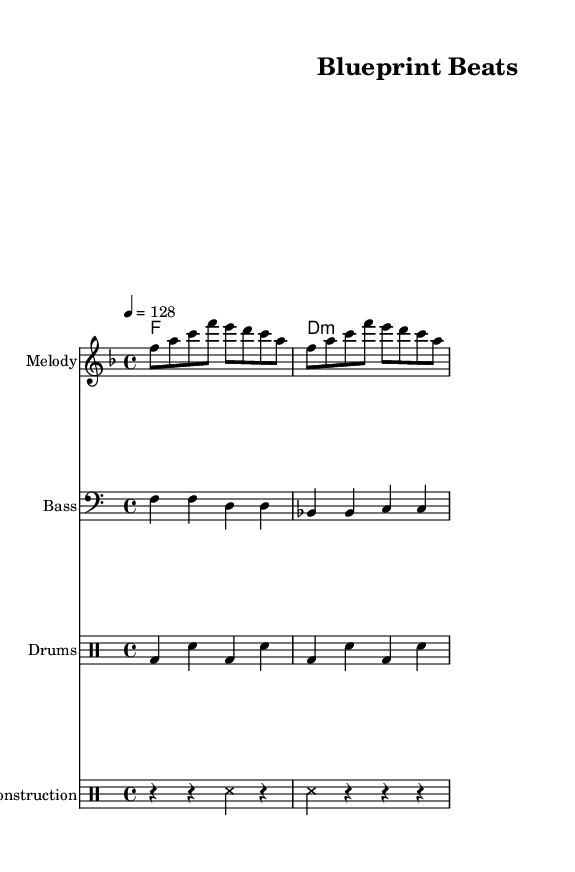What is the key signature of this music? The key signature is F major, which has one flat (B♭). It can be identified from the key signature indicated at the beginning of the staff.
Answer: F major What is the time signature of this music? The time signature is 4/4, which means there are four beats in each measure. This is shown at the beginning of the sheet music after the key signature.
Answer: 4/4 What is the tempo marking of this piece? The tempo marking is 128 beats per minute, indicated by "4 = 128" at the start of the score. This means the quarter note gets the beat, and the tempo is lively.
Answer: 128 How many measures are present in the melody? The melody part consists of two measures, as noted by the notation shown before the bar lines, which divide the music into distinct sections.
Answer: 2 What type of percussion instrument is used in the construction samples? The construction samples utilize sound effects represented by "ss", which stands for a snare sound that mimics rhythmic construction noises. This is noted in the construction drum part.
Answer: Snare What is the overall mood characterization of this piece based on the music type? The overall mood characterization is upbeat, which is common in house music. This can be inferred from the tempo, chosen key, and rhythmic patterns that suggest a motivating and energizing atmosphere for work.
Answer: Upbeat 